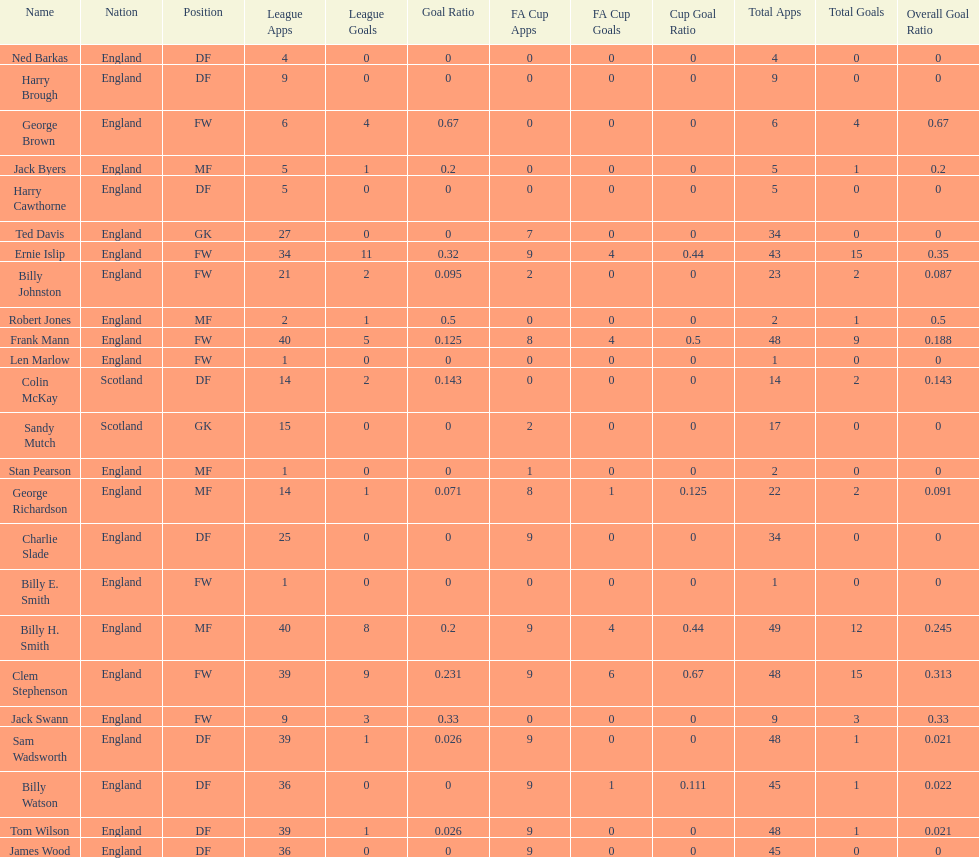How many players are fws? 8. 